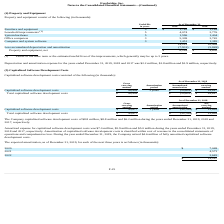According to Everbridge's financial document, What was the Depreciation and amortization expense for the years ended December 31, 2019? According to the financial document, $2.2 million. The relevant text states: "e years ended December 31, 2019, 2018 and 2017 was $2.2 million, $1.8 million and $1.9 million, respectively...." Also, What was the Depreciation and amortization expense for the years ended December 31, 2018? According to the financial document, $1.8 million. The relevant text states: "December 31, 2019, 2018 and 2017 was $2.2 million, $1.8 million and $1.9 million, respectively...." Also, What was the Depreciation and amortization expense for the years ended December 31, 2017? According to the financial document, $1.9 million. The relevant text states: ", 2018 and 2017 was $2.2 million, $1.8 million and $1.9 million, respectively...." Also, can you calculate: What is the change in Furniture and equipment from December 31, 2019 to December 31, 2018? Based on the calculation: 1,785-1,189, the result is 596 (in thousands). This is based on the information: "Furniture and equipment 5 $ 1,785 $ 1,189 Furniture and equipment 5 $ 1,785 $ 1,189..." The key data points involved are: 1,189, 1,785. Also, can you calculate: What is the change in Leasehold improvements from December 31, 2019 to December 31, 2018? Based on the calculation: 4,074-2,776, the result is 1298 (in thousands). This is based on the information: "Leasehold improvements (1) 5 4,074 2,776 Leasehold improvements (1) 5 4,074 2,776..." The key data points involved are: 2,776, 4,074. Also, can you calculate: What is the change in System hardware from December 31, 2019 to December 31, 2018? Based on the calculation: 1,596-1,404, the result is 192 (in thousands). This is based on the information: "System hardware 5 1,596 1,404 System hardware 5 1,596 1,404..." The key data points involved are: 1,404, 1,596. 